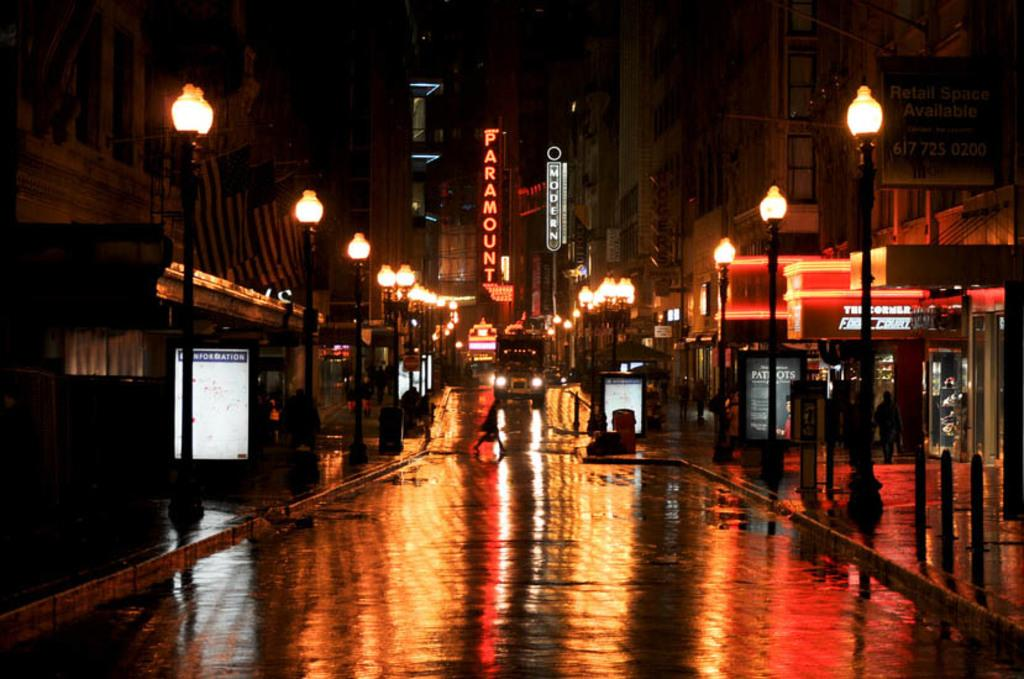What are the people in the image doing? The people in the image are walking. What else can be seen in the image besides people? There are vehicles, stalls, light poles, buildings, and boards in the image. Can you describe the vehicles in the image? The vehicles in the image are not specified, but they are present. What is the color of the sky in the background? The sky in the background appears to be black. What type of glue is being used to hold the buildings together in the image? There is no indication of glue being used to hold the buildings together in the image. Can you see any beetles crawling on the light poles in the image? There are no beetles visible on the light poles in the image. 